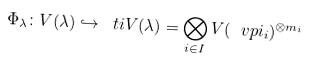Convert formula to latex. <formula><loc_0><loc_0><loc_500><loc_500>\Phi _ { \lambda } \colon V ( \lambda ) \hookrightarrow \ t i { V } ( \lambda ) = \bigotimes _ { i \in I } V ( \ v p i _ { i } ) ^ { \otimes m _ { i } }</formula> 